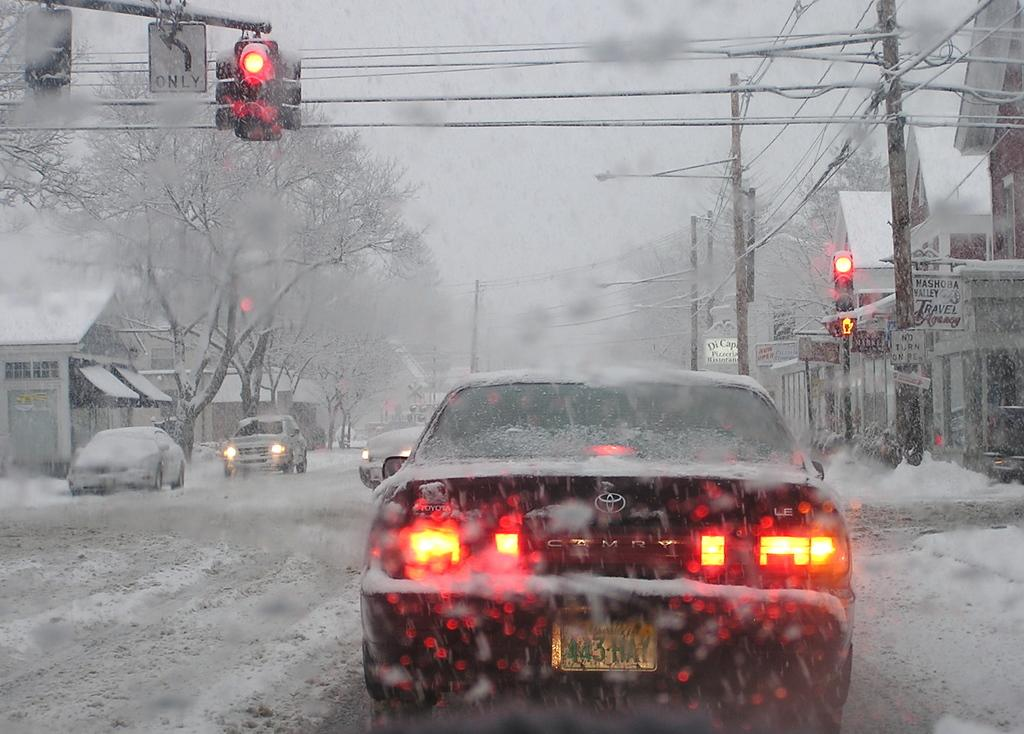What can be seen on the road in the image? There are vehicles on the road in the image. What is the condition of the road? The road is snow-covered. What is present on either side of the road? There are trees and houses on either side of the road. What is the condition of the trees and houses? The trees and houses are covered with snow. What type of list can be seen on the vehicles in the image? There is no list present on the vehicles in the image. What stage of development are the trees and houses in the image? The trees and houses are already developed, as they are visible in the image. 